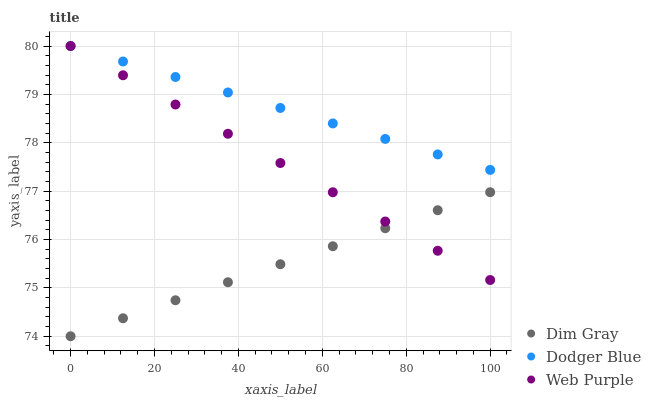Does Dim Gray have the minimum area under the curve?
Answer yes or no. Yes. Does Dodger Blue have the maximum area under the curve?
Answer yes or no. Yes. Does Dodger Blue have the minimum area under the curve?
Answer yes or no. No. Does Dim Gray have the maximum area under the curve?
Answer yes or no. No. Is Dodger Blue the smoothest?
Answer yes or no. Yes. Is Dim Gray the roughest?
Answer yes or no. Yes. Is Dim Gray the smoothest?
Answer yes or no. No. Is Dodger Blue the roughest?
Answer yes or no. No. Does Dim Gray have the lowest value?
Answer yes or no. Yes. Does Dodger Blue have the lowest value?
Answer yes or no. No. Does Dodger Blue have the highest value?
Answer yes or no. Yes. Does Dim Gray have the highest value?
Answer yes or no. No. Is Dim Gray less than Dodger Blue?
Answer yes or no. Yes. Is Dodger Blue greater than Dim Gray?
Answer yes or no. Yes. Does Dim Gray intersect Web Purple?
Answer yes or no. Yes. Is Dim Gray less than Web Purple?
Answer yes or no. No. Is Dim Gray greater than Web Purple?
Answer yes or no. No. Does Dim Gray intersect Dodger Blue?
Answer yes or no. No. 